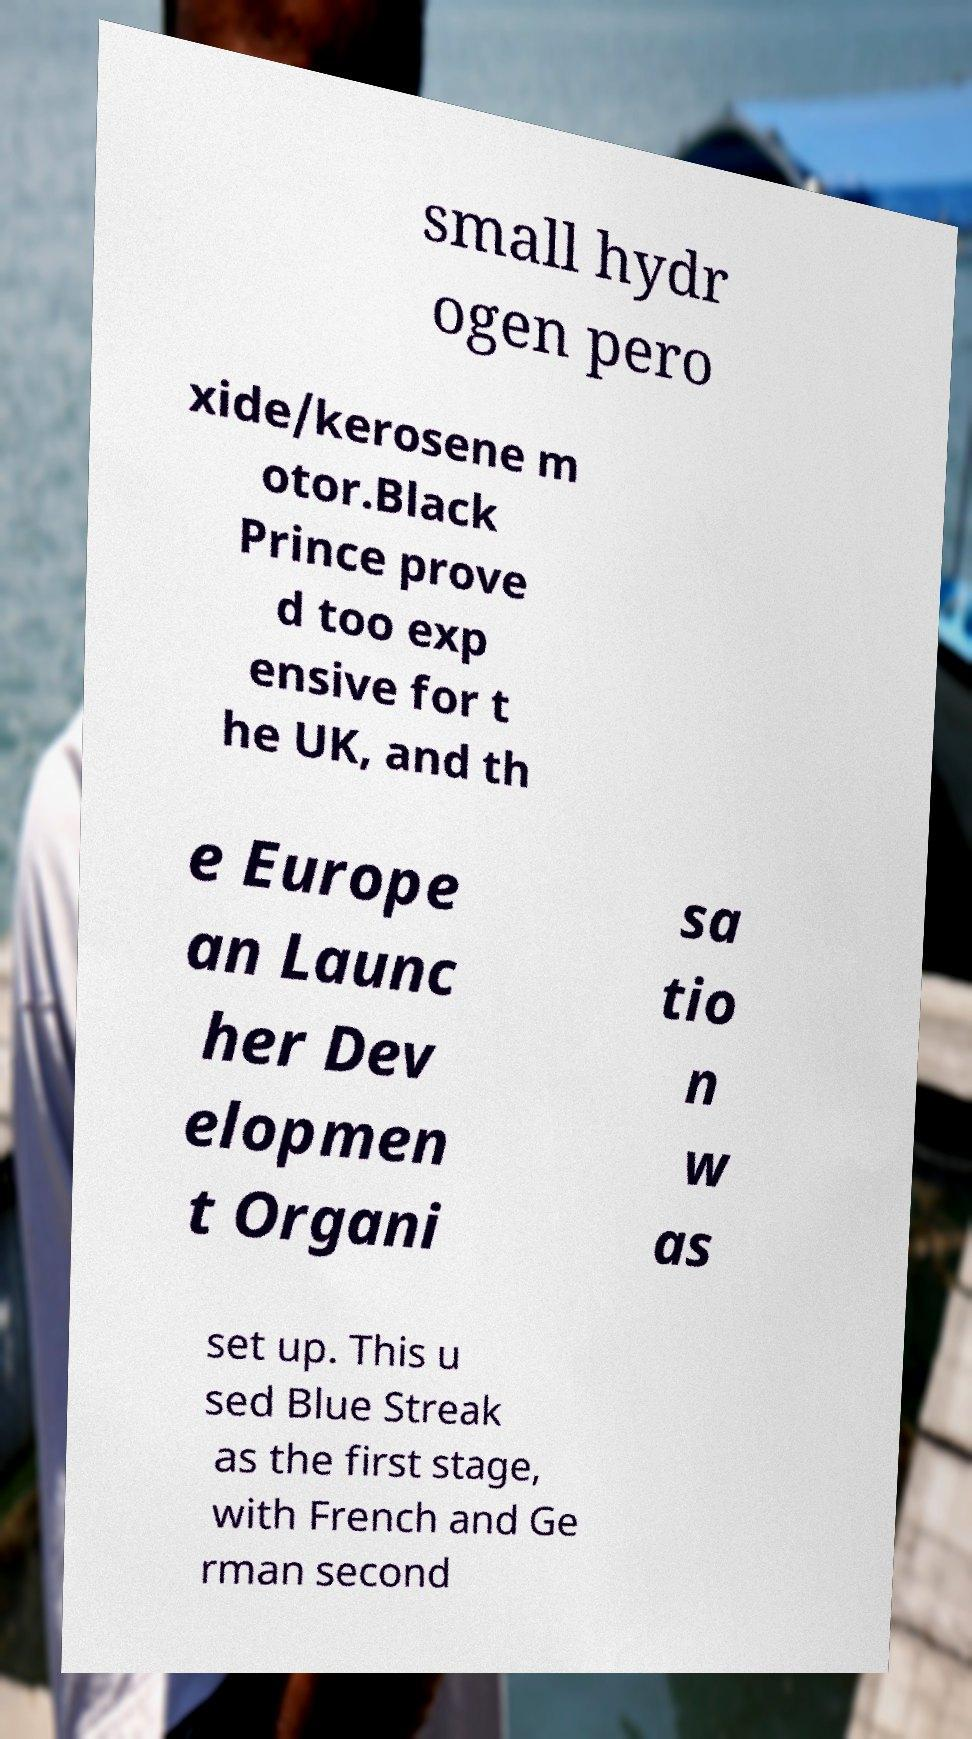For documentation purposes, I need the text within this image transcribed. Could you provide that? small hydr ogen pero xide/kerosene m otor.Black Prince prove d too exp ensive for t he UK, and th e Europe an Launc her Dev elopmen t Organi sa tio n w as set up. This u sed Blue Streak as the first stage, with French and Ge rman second 